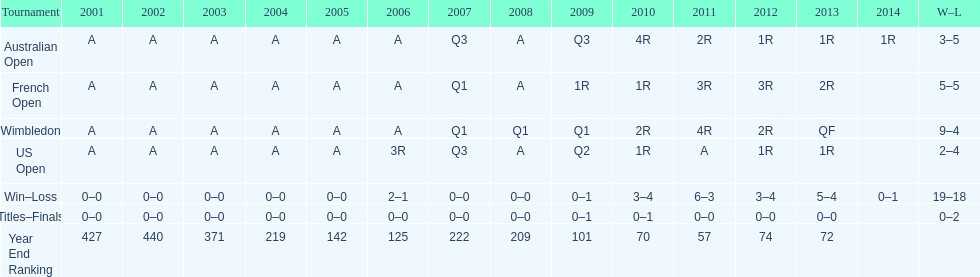In how many competitions were there 5 total defeats? 2. 